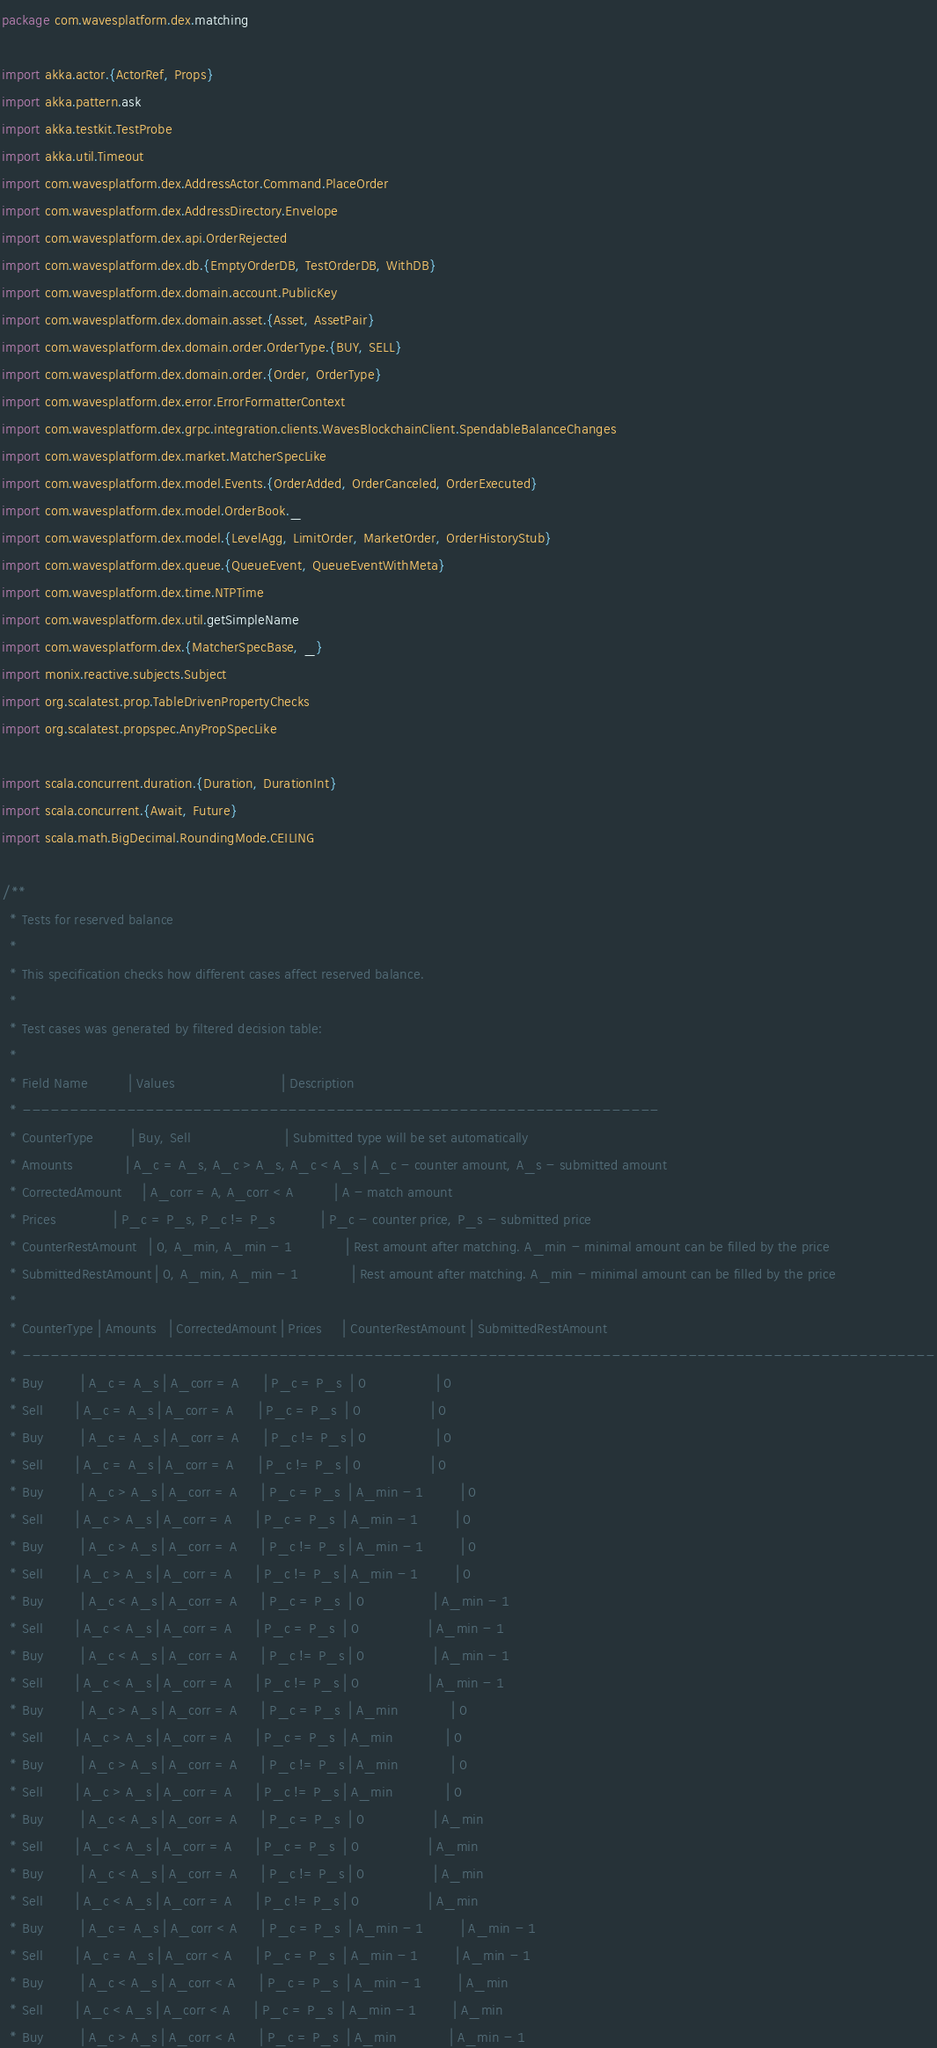<code> <loc_0><loc_0><loc_500><loc_500><_Scala_>package com.wavesplatform.dex.matching

import akka.actor.{ActorRef, Props}
import akka.pattern.ask
import akka.testkit.TestProbe
import akka.util.Timeout
import com.wavesplatform.dex.AddressActor.Command.PlaceOrder
import com.wavesplatform.dex.AddressDirectory.Envelope
import com.wavesplatform.dex.api.OrderRejected
import com.wavesplatform.dex.db.{EmptyOrderDB, TestOrderDB, WithDB}
import com.wavesplatform.dex.domain.account.PublicKey
import com.wavesplatform.dex.domain.asset.{Asset, AssetPair}
import com.wavesplatform.dex.domain.order.OrderType.{BUY, SELL}
import com.wavesplatform.dex.domain.order.{Order, OrderType}
import com.wavesplatform.dex.error.ErrorFormatterContext
import com.wavesplatform.dex.grpc.integration.clients.WavesBlockchainClient.SpendableBalanceChanges
import com.wavesplatform.dex.market.MatcherSpecLike
import com.wavesplatform.dex.model.Events.{OrderAdded, OrderCanceled, OrderExecuted}
import com.wavesplatform.dex.model.OrderBook._
import com.wavesplatform.dex.model.{LevelAgg, LimitOrder, MarketOrder, OrderHistoryStub}
import com.wavesplatform.dex.queue.{QueueEvent, QueueEventWithMeta}
import com.wavesplatform.dex.time.NTPTime
import com.wavesplatform.dex.util.getSimpleName
import com.wavesplatform.dex.{MatcherSpecBase, _}
import monix.reactive.subjects.Subject
import org.scalatest.prop.TableDrivenPropertyChecks
import org.scalatest.propspec.AnyPropSpecLike

import scala.concurrent.duration.{Duration, DurationInt}
import scala.concurrent.{Await, Future}
import scala.math.BigDecimal.RoundingMode.CEILING

/**
  * Tests for reserved balance
  *
  * This specification checks how different cases affect reserved balance.
  *
  * Test cases was generated by filtered decision table:
  *
  * Field Name          | Values                          | Description
  * -------------------------------------------------------------------
  * CounterType         | Buy, Sell                       | Submitted type will be set automatically
  * Amounts             | A_c = A_s, A_c > A_s, A_c < A_s | A_c - counter amount, A_s - submitted amount
  * CorrectedAmount     | A_corr = A, A_corr < A          | A - match amount
  * Prices              | P_c = P_s, P_c != P_s           | P_c - counter price, P_s - submitted price
  * CounterRestAmount   | 0, A_min, A_min - 1             | Rest amount after matching. A_min - minimal amount can be filled by the price
  * SubmittedRestAmount | 0, A_min, A_min - 1             | Rest amount after matching. A_min - minimal amount can be filled by the price
  *
  * CounterType | Amounts   | CorrectedAmount | Prices     | CounterRestAmount | SubmittedRestAmount
  * ------------------------------------------------------------------------------------------------
  * Buy         | A_c = A_s | A_corr = A      | P_c = P_s  | 0                 | 0
  * Sell        | A_c = A_s | A_corr = A      | P_c = P_s  | 0                 | 0
  * Buy         | A_c = A_s | A_corr = A      | P_c != P_s | 0                 | 0
  * Sell        | A_c = A_s | A_corr = A      | P_c != P_s | 0                 | 0
  * Buy         | A_c > A_s | A_corr = A      | P_c = P_s  | A_min - 1         | 0
  * Sell        | A_c > A_s | A_corr = A      | P_c = P_s  | A_min - 1         | 0
  * Buy         | A_c > A_s | A_corr = A      | P_c != P_s | A_min - 1         | 0
  * Sell        | A_c > A_s | A_corr = A      | P_c != P_s | A_min - 1         | 0
  * Buy         | A_c < A_s | A_corr = A      | P_c = P_s  | 0                 | A_min - 1
  * Sell        | A_c < A_s | A_corr = A      | P_c = P_s  | 0                 | A_min - 1
  * Buy         | A_c < A_s | A_corr = A      | P_c != P_s | 0                 | A_min - 1
  * Sell        | A_c < A_s | A_corr = A      | P_c != P_s | 0                 | A_min - 1
  * Buy         | A_c > A_s | A_corr = A      | P_c = P_s  | A_min             | 0
  * Sell        | A_c > A_s | A_corr = A      | P_c = P_s  | A_min             | 0
  * Buy         | A_c > A_s | A_corr = A      | P_c != P_s | A_min             | 0
  * Sell        | A_c > A_s | A_corr = A      | P_c != P_s | A_min             | 0
  * Buy         | A_c < A_s | A_corr = A      | P_c = P_s  | 0                 | A_min
  * Sell        | A_c < A_s | A_corr = A      | P_c = P_s  | 0                 | A_min
  * Buy         | A_c < A_s | A_corr = A      | P_c != P_s | 0                 | A_min
  * Sell        | A_c < A_s | A_corr = A      | P_c != P_s | 0                 | A_min
  * Buy         | A_c = A_s | A_corr < A      | P_c = P_s  | A_min - 1         | A_min - 1
  * Sell        | A_c = A_s | A_corr < A      | P_c = P_s  | A_min - 1         | A_min - 1
  * Buy         | A_c < A_s | A_corr < A      | P_c = P_s  | A_min - 1         | A_min
  * Sell        | A_c < A_s | A_corr < A      | P_c = P_s  | A_min - 1         | A_min
  * Buy         | A_c > A_s | A_corr < A      | P_c = P_s  | A_min             | A_min - 1</code> 